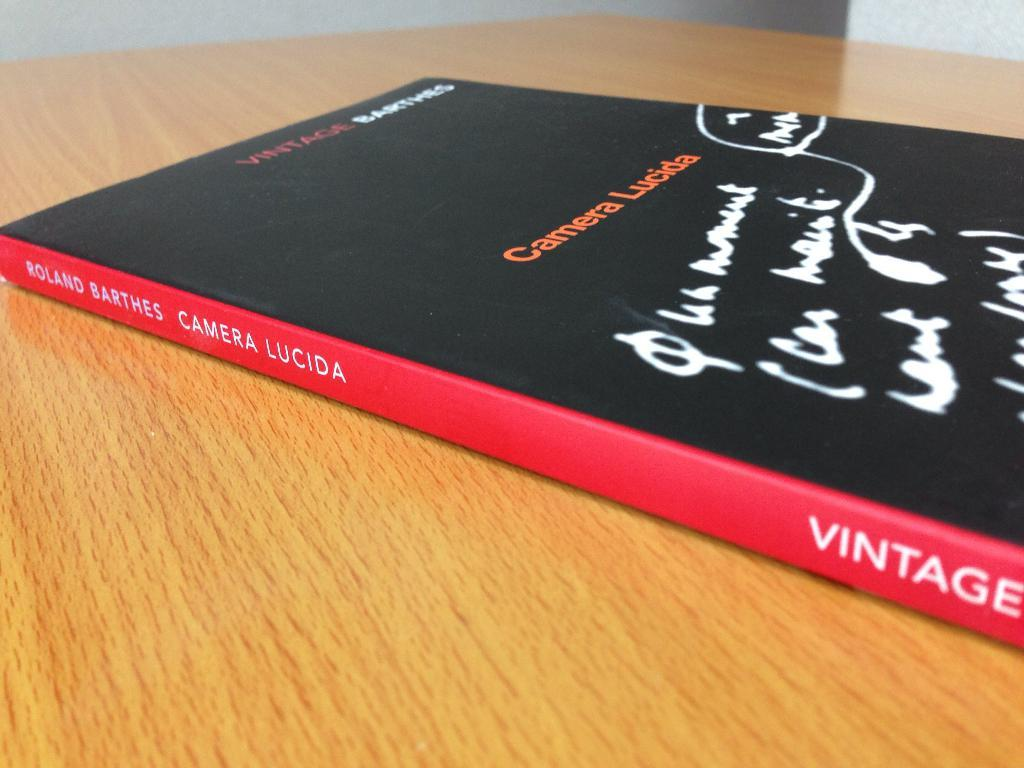<image>
Present a compact description of the photo's key features. A book called Camera Lucida on a wooden table. 